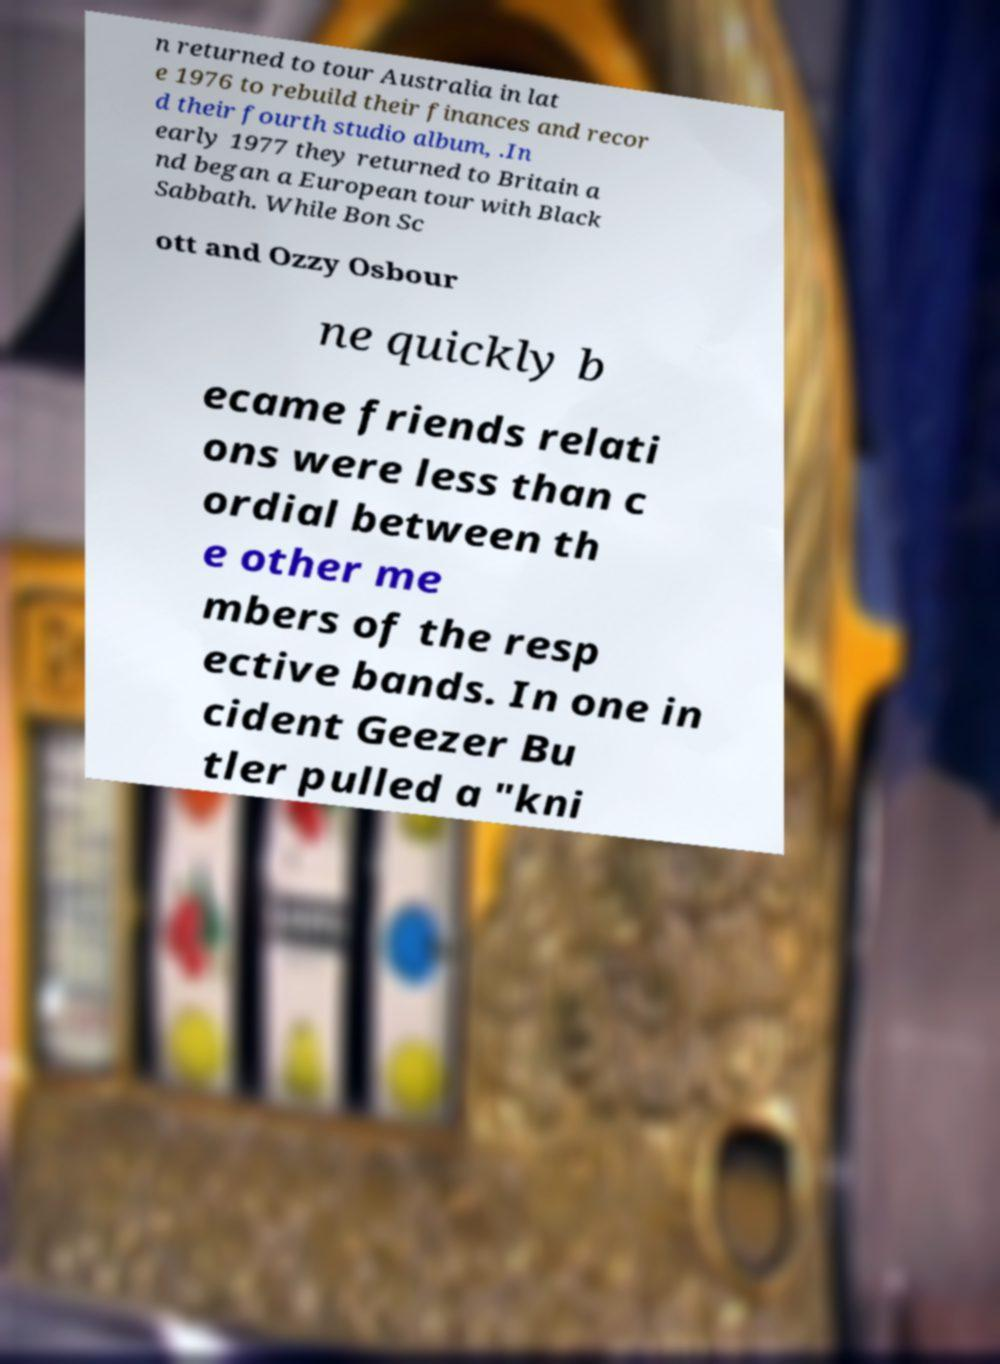Please identify and transcribe the text found in this image. n returned to tour Australia in lat e 1976 to rebuild their finances and recor d their fourth studio album, .In early 1977 they returned to Britain a nd began a European tour with Black Sabbath. While Bon Sc ott and Ozzy Osbour ne quickly b ecame friends relati ons were less than c ordial between th e other me mbers of the resp ective bands. In one in cident Geezer Bu tler pulled a "kni 